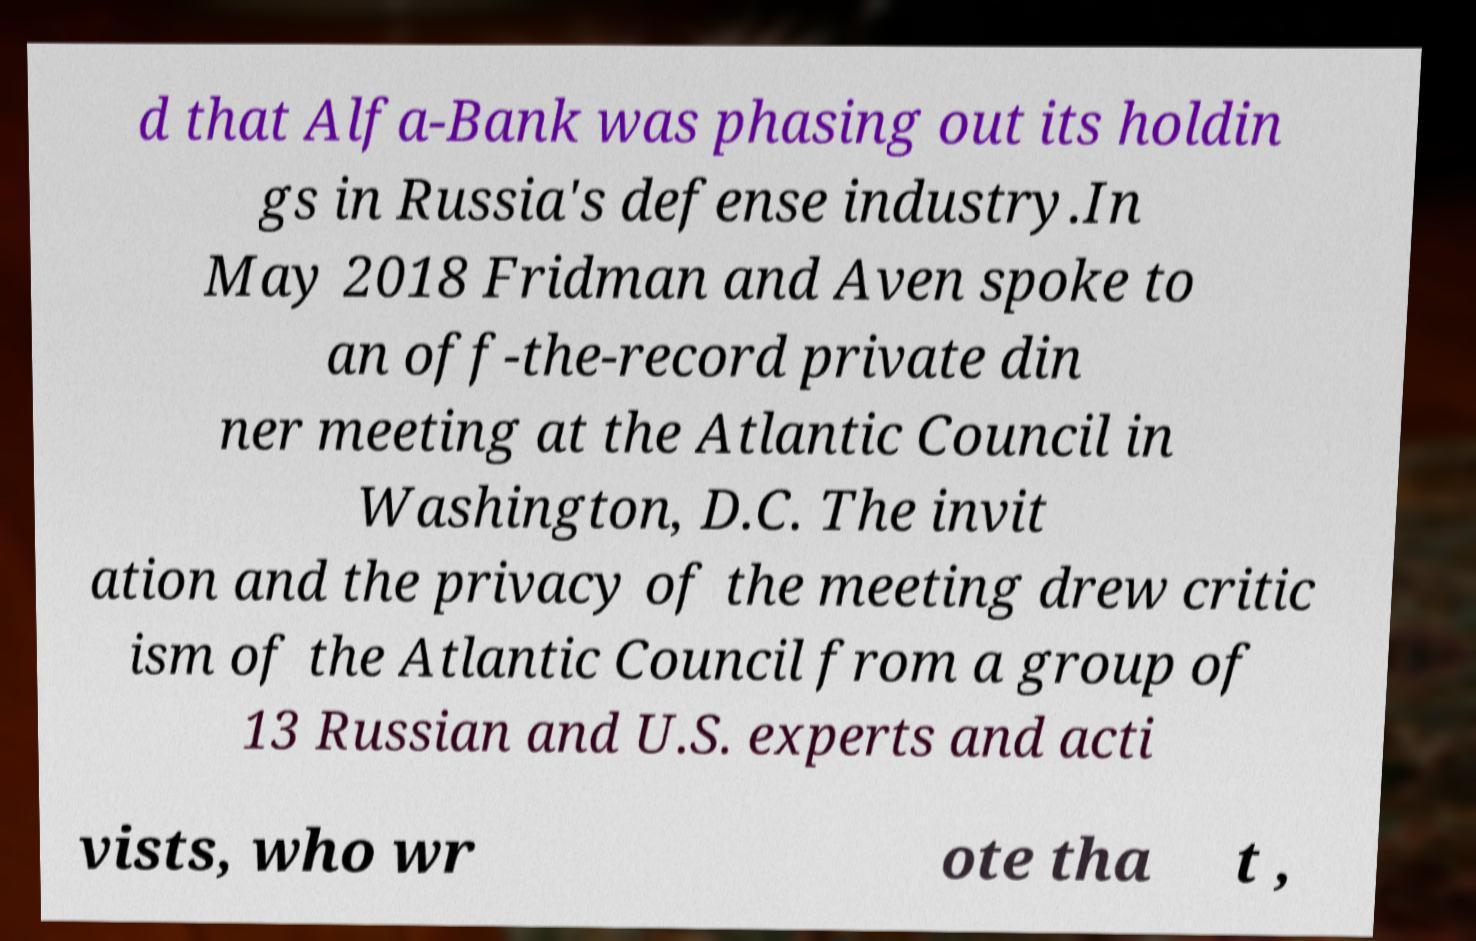Could you assist in decoding the text presented in this image and type it out clearly? d that Alfa-Bank was phasing out its holdin gs in Russia's defense industry.In May 2018 Fridman and Aven spoke to an off-the-record private din ner meeting at the Atlantic Council in Washington, D.C. The invit ation and the privacy of the meeting drew critic ism of the Atlantic Council from a group of 13 Russian and U.S. experts and acti vists, who wr ote tha t , 